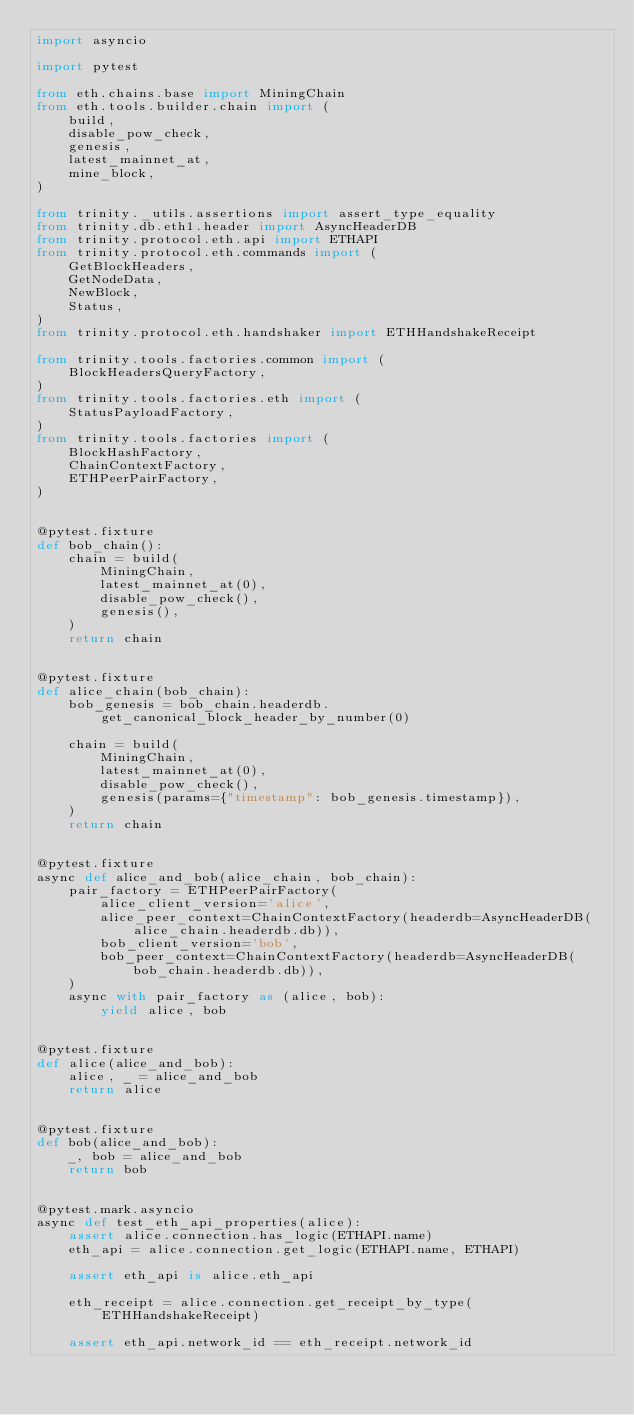Convert code to text. <code><loc_0><loc_0><loc_500><loc_500><_Python_>import asyncio

import pytest

from eth.chains.base import MiningChain
from eth.tools.builder.chain import (
    build,
    disable_pow_check,
    genesis,
    latest_mainnet_at,
    mine_block,
)

from trinity._utils.assertions import assert_type_equality
from trinity.db.eth1.header import AsyncHeaderDB
from trinity.protocol.eth.api import ETHAPI
from trinity.protocol.eth.commands import (
    GetBlockHeaders,
    GetNodeData,
    NewBlock,
    Status,
)
from trinity.protocol.eth.handshaker import ETHHandshakeReceipt

from trinity.tools.factories.common import (
    BlockHeadersQueryFactory,
)
from trinity.tools.factories.eth import (
    StatusPayloadFactory,
)
from trinity.tools.factories import (
    BlockHashFactory,
    ChainContextFactory,
    ETHPeerPairFactory,
)


@pytest.fixture
def bob_chain():
    chain = build(
        MiningChain,
        latest_mainnet_at(0),
        disable_pow_check(),
        genesis(),
    )
    return chain


@pytest.fixture
def alice_chain(bob_chain):
    bob_genesis = bob_chain.headerdb.get_canonical_block_header_by_number(0)

    chain = build(
        MiningChain,
        latest_mainnet_at(0),
        disable_pow_check(),
        genesis(params={"timestamp": bob_genesis.timestamp}),
    )
    return chain


@pytest.fixture
async def alice_and_bob(alice_chain, bob_chain):
    pair_factory = ETHPeerPairFactory(
        alice_client_version='alice',
        alice_peer_context=ChainContextFactory(headerdb=AsyncHeaderDB(alice_chain.headerdb.db)),
        bob_client_version='bob',
        bob_peer_context=ChainContextFactory(headerdb=AsyncHeaderDB(bob_chain.headerdb.db)),
    )
    async with pair_factory as (alice, bob):
        yield alice, bob


@pytest.fixture
def alice(alice_and_bob):
    alice, _ = alice_and_bob
    return alice


@pytest.fixture
def bob(alice_and_bob):
    _, bob = alice_and_bob
    return bob


@pytest.mark.asyncio
async def test_eth_api_properties(alice):
    assert alice.connection.has_logic(ETHAPI.name)
    eth_api = alice.connection.get_logic(ETHAPI.name, ETHAPI)

    assert eth_api is alice.eth_api

    eth_receipt = alice.connection.get_receipt_by_type(ETHHandshakeReceipt)

    assert eth_api.network_id == eth_receipt.network_id</code> 